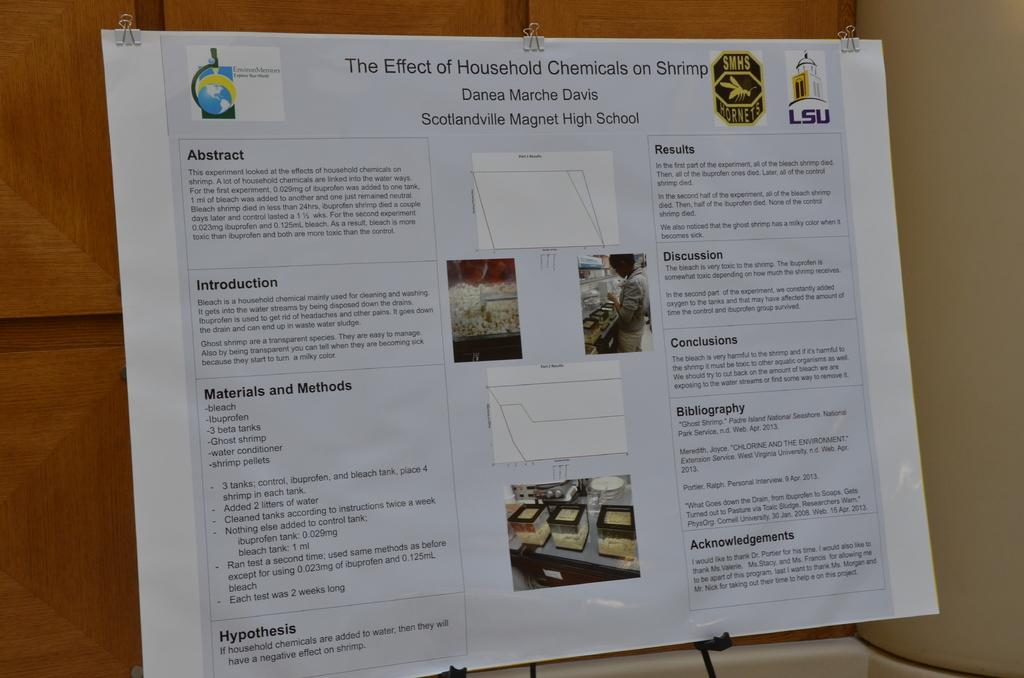<image>
Present a compact description of the photo's key features. A presentation board for the Effect of Household Chemicals on Shrimp is placed on a easel. 